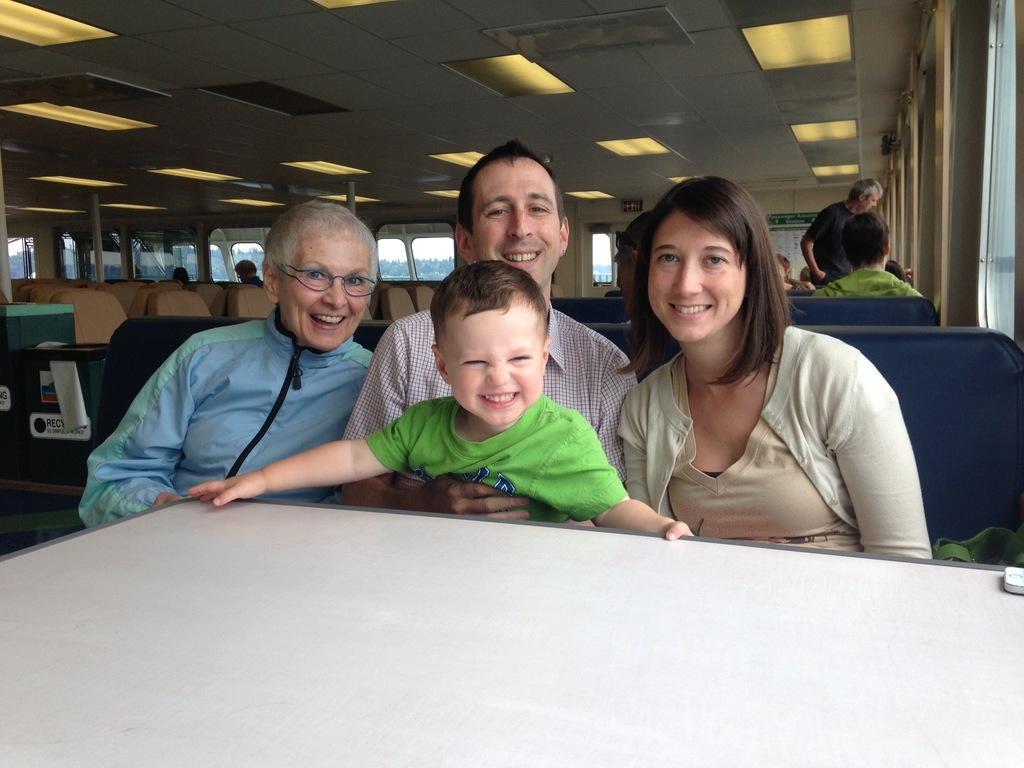Describe this image in one or two sentences. In this picture we can see four persons in focus and they are smiling and in front of them there is a empty table and in background we can see windows, some more persons, chairs. 